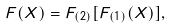Convert formula to latex. <formula><loc_0><loc_0><loc_500><loc_500>F ( X ) = F _ { ( 2 ) } [ F _ { ( 1 ) } ( X ) ] ,</formula> 